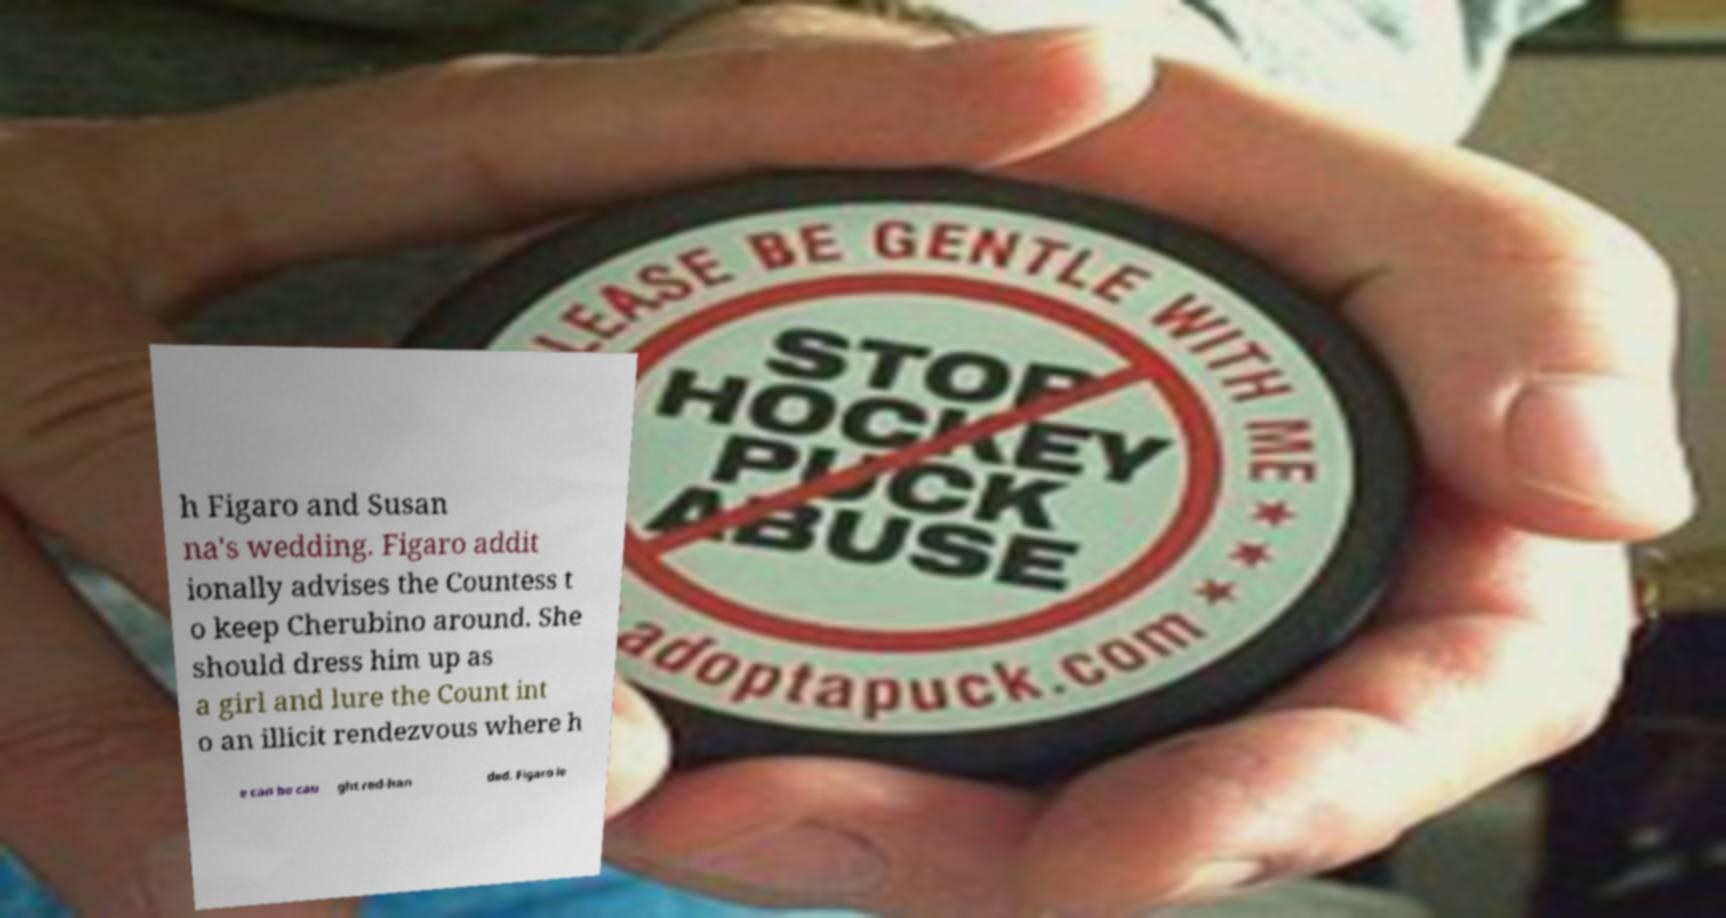Could you extract and type out the text from this image? h Figaro and Susan na's wedding. Figaro addit ionally advises the Countess t o keep Cherubino around. She should dress him up as a girl and lure the Count int o an illicit rendezvous where h e can be cau ght red-han ded. Figaro le 